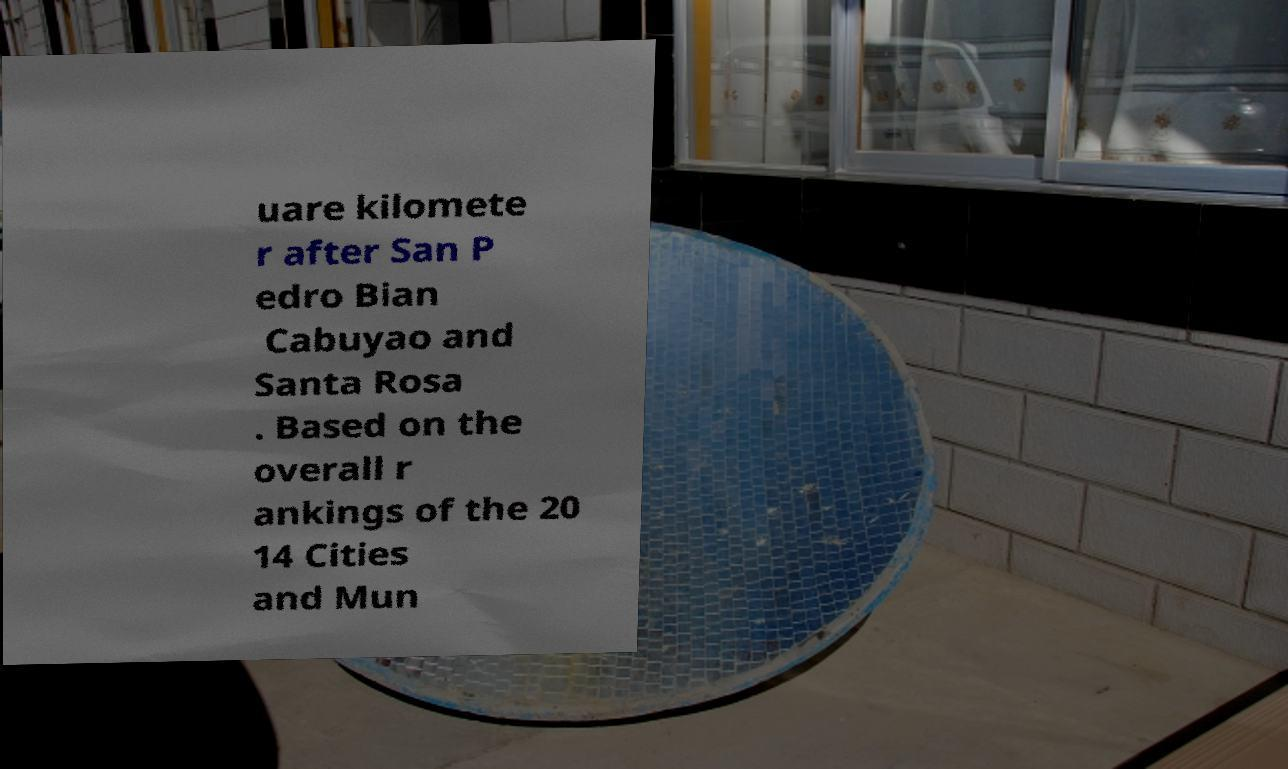What messages or text are displayed in this image? I need them in a readable, typed format. uare kilomete r after San P edro Bian Cabuyao and Santa Rosa . Based on the overall r ankings of the 20 14 Cities and Mun 